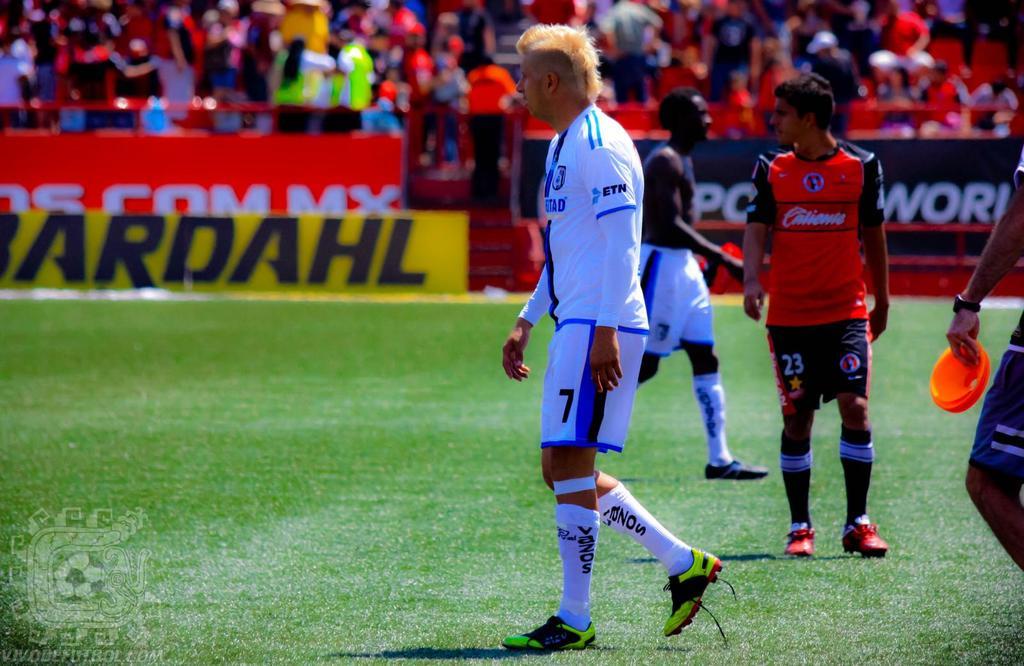What number is the player in white?
Make the answer very short. 7. What is on the players arm?
Your response must be concise. Etn. 